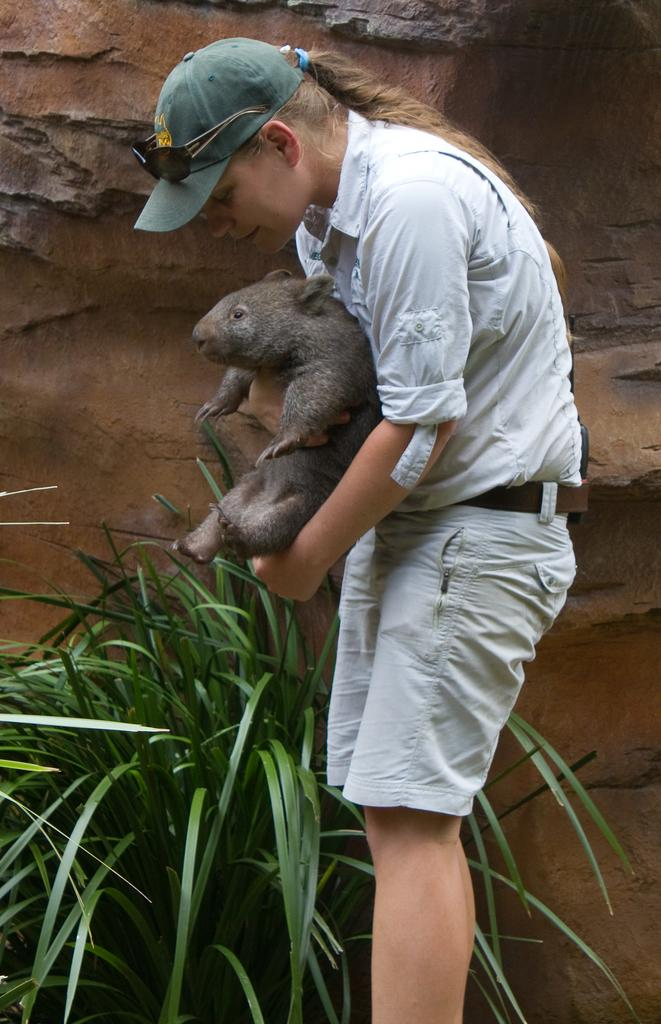Who is present in the image? There is a woman in the image. Where is the woman located in the image? The woman is standing in the middle of the image. What is the woman holding in the image? The woman is holding an animal. What other objects or elements can be seen in the image? There is a plant and a wall in the image. What type of drum is the woman playing in the image? There is no drum present in the image; the woman is holding an animal. 